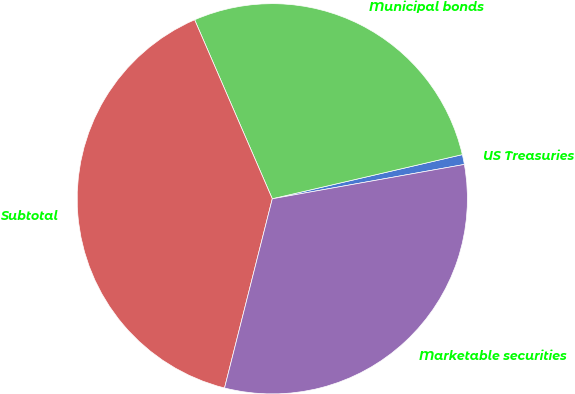Convert chart to OTSL. <chart><loc_0><loc_0><loc_500><loc_500><pie_chart><fcel>US Treasuries<fcel>Municipal bonds<fcel>Subtotal<fcel>Marketable securities<nl><fcel>0.82%<fcel>27.88%<fcel>39.55%<fcel>31.75%<nl></chart> 